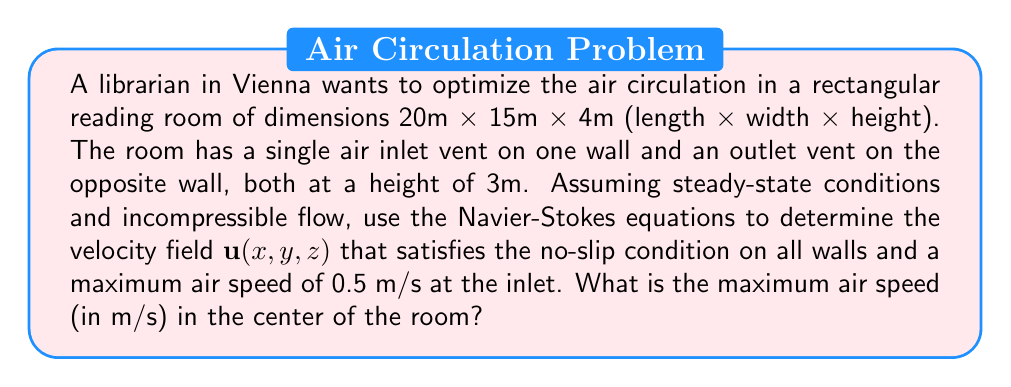Provide a solution to this math problem. To solve this problem, we'll use the steady-state, incompressible Navier-Stokes equations in 3D:

$$\nabla \cdot \mathbf{u} = 0$$
$$(\mathbf{u} \cdot \nabla)\mathbf{u} = -\frac{1}{\rho}\nabla p + \nu \nabla^2\mathbf{u}$$

Where $\mathbf{u}$ is the velocity field, $p$ is pressure, $\rho$ is density, and $\nu$ is kinematic viscosity.

Given the symmetry of the problem, we can simplify by assuming the flow is primarily in the x-direction (along the length of the room). We'll use a simplified model:

$$u(x,y,z) = U_0 \sin(\frac{\pi y}{W}) \sin(\frac{\pi z}{H}) (1 - \frac{x}{L})$$
$$v(x,y,z) = w(x,y,z) = 0$$

Where $U_0$ is the maximum velocity at the inlet, $W$ is the width, $H$ is the height, and $L$ is the length of the room.

This velocity field satisfies:
1. No-slip condition on walls (u = 0 at y = 0, y = W, z = 0, z = H)
2. Maximum velocity $U_0$ at the inlet (x = 0)
3. Zero velocity at the outlet (x = L)

To find $U_0$, we use the given maximum air speed at the inlet:

$$0.5 = U_0 \sin(\frac{\pi 7.5}{15}) \sin(\frac{\pi 3}{4})$$

Solving this, we get $U_0 \approx 0.7155$ m/s.

The velocity at the center of the room (x = 10m, y = 7.5m, z = 2m) is:

$$u(10,7.5,2) = 0.7155 \sin(\frac{\pi 7.5}{15}) \sin(\frac{\pi 2}{4}) (1 - \frac{10}{20})$$
Answer: The maximum air speed in the center of the room is approximately 0.1767 m/s. 